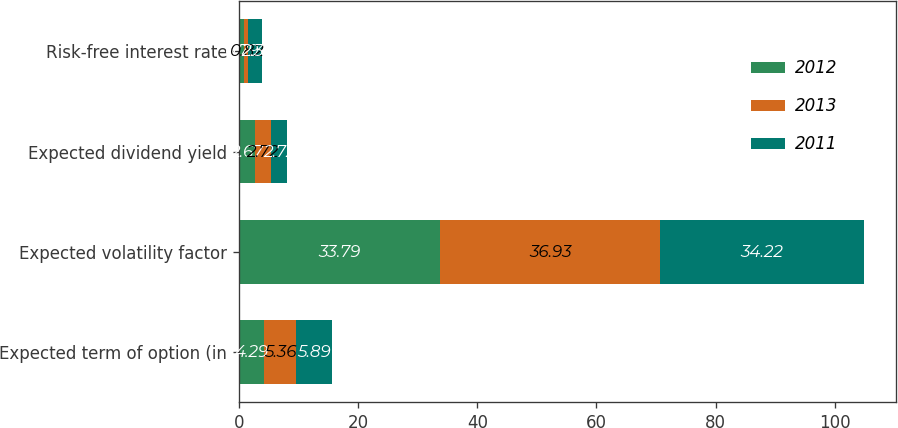<chart> <loc_0><loc_0><loc_500><loc_500><stacked_bar_chart><ecel><fcel>Expected term of option (in<fcel>Expected volatility factor<fcel>Expected dividend yield<fcel>Risk-free interest rate<nl><fcel>2012<fcel>4.29<fcel>33.79<fcel>2.67<fcel>0.79<nl><fcel>2013<fcel>5.36<fcel>36.93<fcel>2.72<fcel>0.82<nl><fcel>2011<fcel>5.89<fcel>34.22<fcel>2.72<fcel>2.31<nl></chart> 